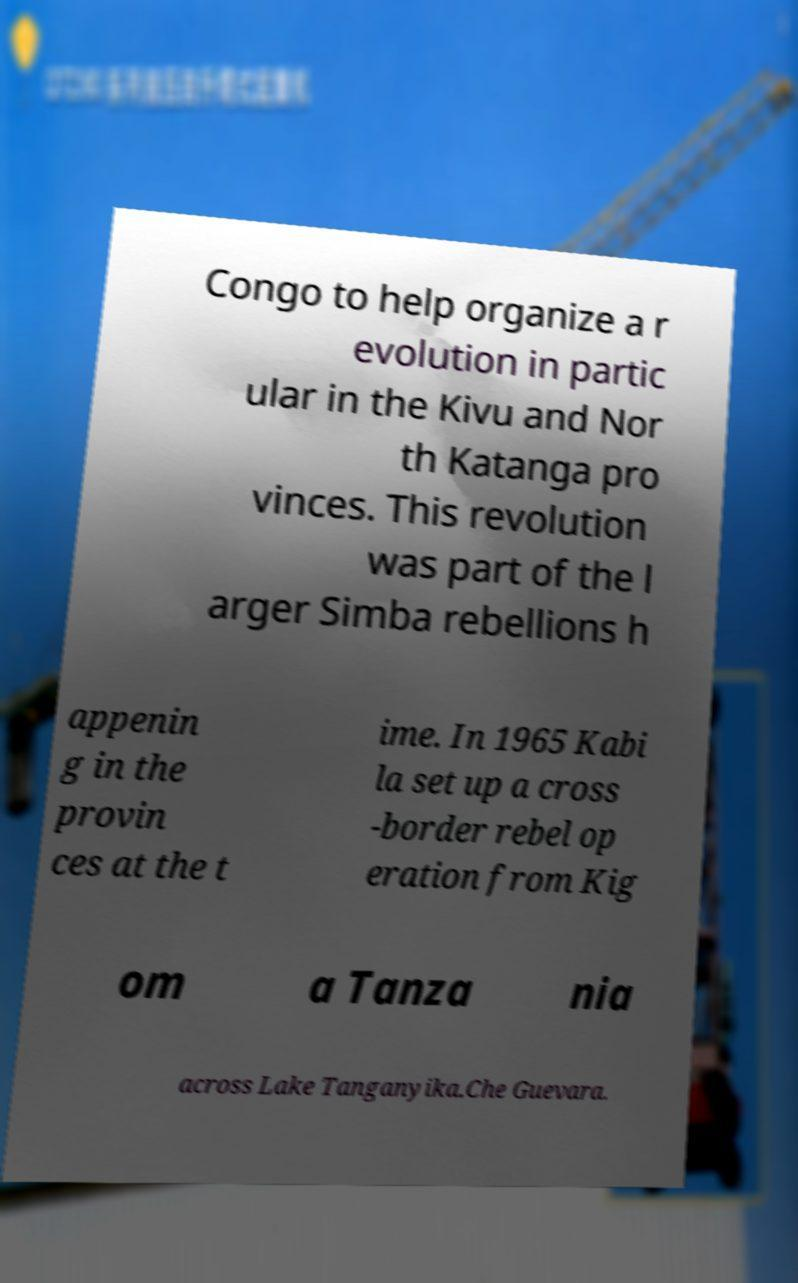Could you assist in decoding the text presented in this image and type it out clearly? Congo to help organize a r evolution in partic ular in the Kivu and Nor th Katanga pro vinces. This revolution was part of the l arger Simba rebellions h appenin g in the provin ces at the t ime. In 1965 Kabi la set up a cross -border rebel op eration from Kig om a Tanza nia across Lake Tanganyika.Che Guevara. 